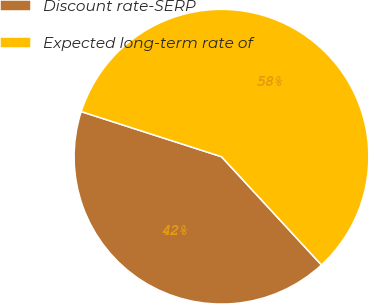Convert chart to OTSL. <chart><loc_0><loc_0><loc_500><loc_500><pie_chart><fcel>Discount rate-SERP<fcel>Expected long-term rate of<nl><fcel>41.82%<fcel>58.18%<nl></chart> 